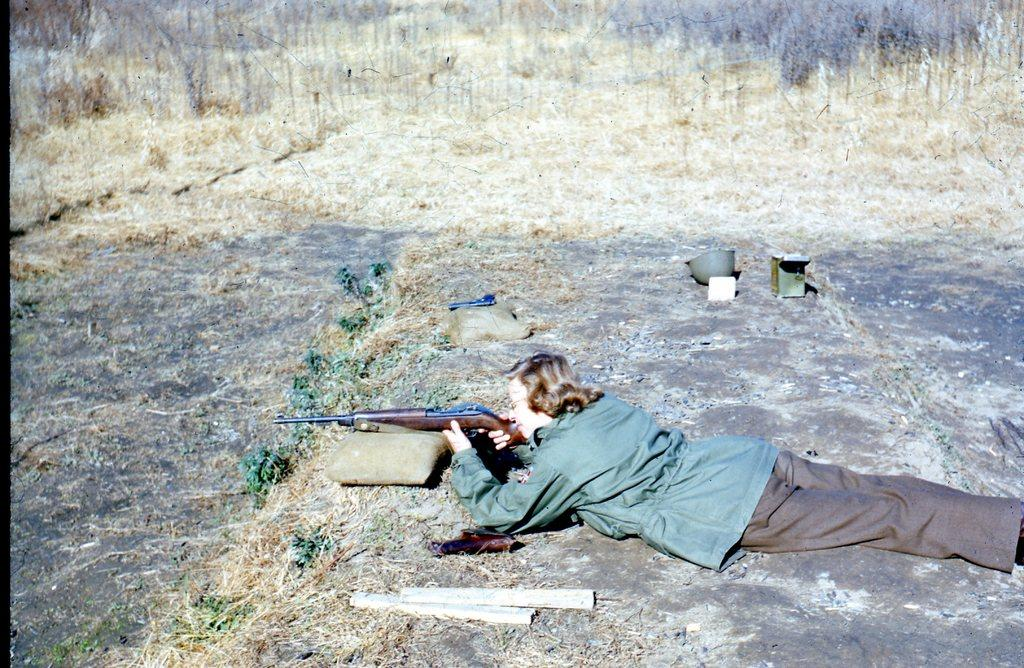Who is present in the image? There is a man in the image. What is the man's position in the image? The man is lying on a rock surface. What is the man holding in the image? The man is holding a rifle. What else can be seen related to weapons in the image? There is a pistol on a rice sack bag in the image. What type of vegetation is present on the ground in the image? There is dry grass on the ground in the image. What type of metal can be seen in the stem of the hole in the image? There is no metal, stem, or hole present in the image. 